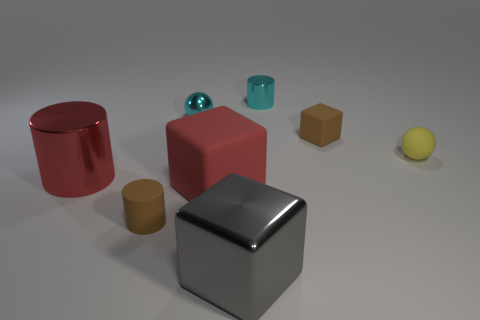Add 2 big red shiny spheres. How many objects exist? 10 Subtract all cylinders. How many objects are left? 5 Subtract all large gray rubber cubes. Subtract all brown rubber blocks. How many objects are left? 7 Add 3 big red matte blocks. How many big red matte blocks are left? 4 Add 8 large purple balls. How many large purple balls exist? 8 Subtract 0 gray balls. How many objects are left? 8 